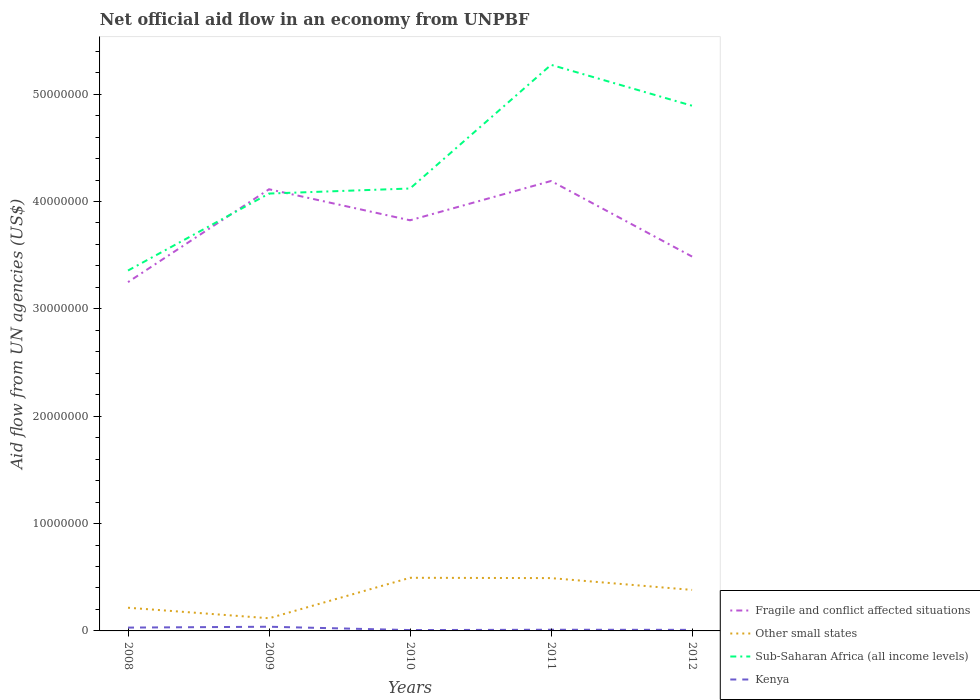How many different coloured lines are there?
Give a very brief answer. 4. What is the difference between the highest and the second highest net official aid flow in Fragile and conflict affected situations?
Your answer should be very brief. 9.42e+06. What is the difference between the highest and the lowest net official aid flow in Kenya?
Keep it short and to the point. 2. How many lines are there?
Your answer should be very brief. 4. How many years are there in the graph?
Your answer should be compact. 5. Are the values on the major ticks of Y-axis written in scientific E-notation?
Your answer should be compact. No. Does the graph contain any zero values?
Make the answer very short. No. Does the graph contain grids?
Provide a succinct answer. No. Where does the legend appear in the graph?
Your answer should be very brief. Bottom right. How many legend labels are there?
Make the answer very short. 4. How are the legend labels stacked?
Provide a succinct answer. Vertical. What is the title of the graph?
Keep it short and to the point. Net official aid flow in an economy from UNPBF. What is the label or title of the Y-axis?
Your answer should be very brief. Aid flow from UN agencies (US$). What is the Aid flow from UN agencies (US$) of Fragile and conflict affected situations in 2008?
Your answer should be compact. 3.25e+07. What is the Aid flow from UN agencies (US$) in Other small states in 2008?
Your answer should be very brief. 2.16e+06. What is the Aid flow from UN agencies (US$) in Sub-Saharan Africa (all income levels) in 2008?
Your answer should be compact. 3.36e+07. What is the Aid flow from UN agencies (US$) in Fragile and conflict affected situations in 2009?
Your answer should be very brief. 4.11e+07. What is the Aid flow from UN agencies (US$) in Other small states in 2009?
Give a very brief answer. 1.18e+06. What is the Aid flow from UN agencies (US$) in Sub-Saharan Africa (all income levels) in 2009?
Offer a terse response. 4.07e+07. What is the Aid flow from UN agencies (US$) in Fragile and conflict affected situations in 2010?
Your answer should be compact. 3.82e+07. What is the Aid flow from UN agencies (US$) in Other small states in 2010?
Offer a terse response. 4.95e+06. What is the Aid flow from UN agencies (US$) of Sub-Saharan Africa (all income levels) in 2010?
Give a very brief answer. 4.12e+07. What is the Aid flow from UN agencies (US$) of Fragile and conflict affected situations in 2011?
Your answer should be compact. 4.19e+07. What is the Aid flow from UN agencies (US$) in Other small states in 2011?
Your answer should be compact. 4.92e+06. What is the Aid flow from UN agencies (US$) in Sub-Saharan Africa (all income levels) in 2011?
Keep it short and to the point. 5.27e+07. What is the Aid flow from UN agencies (US$) in Fragile and conflict affected situations in 2012?
Provide a succinct answer. 3.49e+07. What is the Aid flow from UN agencies (US$) of Other small states in 2012?
Give a very brief answer. 3.82e+06. What is the Aid flow from UN agencies (US$) of Sub-Saharan Africa (all income levels) in 2012?
Provide a short and direct response. 4.89e+07. What is the Aid flow from UN agencies (US$) in Kenya in 2012?
Give a very brief answer. 1.00e+05. Across all years, what is the maximum Aid flow from UN agencies (US$) in Fragile and conflict affected situations?
Give a very brief answer. 4.19e+07. Across all years, what is the maximum Aid flow from UN agencies (US$) in Other small states?
Offer a very short reply. 4.95e+06. Across all years, what is the maximum Aid flow from UN agencies (US$) of Sub-Saharan Africa (all income levels)?
Give a very brief answer. 5.27e+07. Across all years, what is the maximum Aid flow from UN agencies (US$) in Kenya?
Keep it short and to the point. 3.90e+05. Across all years, what is the minimum Aid flow from UN agencies (US$) of Fragile and conflict affected situations?
Provide a succinct answer. 3.25e+07. Across all years, what is the minimum Aid flow from UN agencies (US$) of Other small states?
Keep it short and to the point. 1.18e+06. Across all years, what is the minimum Aid flow from UN agencies (US$) in Sub-Saharan Africa (all income levels)?
Offer a very short reply. 3.36e+07. Across all years, what is the minimum Aid flow from UN agencies (US$) of Kenya?
Offer a terse response. 8.00e+04. What is the total Aid flow from UN agencies (US$) in Fragile and conflict affected situations in the graph?
Keep it short and to the point. 1.89e+08. What is the total Aid flow from UN agencies (US$) of Other small states in the graph?
Keep it short and to the point. 1.70e+07. What is the total Aid flow from UN agencies (US$) of Sub-Saharan Africa (all income levels) in the graph?
Your answer should be very brief. 2.17e+08. What is the total Aid flow from UN agencies (US$) of Kenya in the graph?
Provide a short and direct response. 9.90e+05. What is the difference between the Aid flow from UN agencies (US$) in Fragile and conflict affected situations in 2008 and that in 2009?
Offer a terse response. -8.65e+06. What is the difference between the Aid flow from UN agencies (US$) in Other small states in 2008 and that in 2009?
Offer a terse response. 9.80e+05. What is the difference between the Aid flow from UN agencies (US$) in Sub-Saharan Africa (all income levels) in 2008 and that in 2009?
Offer a very short reply. -7.17e+06. What is the difference between the Aid flow from UN agencies (US$) of Fragile and conflict affected situations in 2008 and that in 2010?
Offer a terse response. -5.76e+06. What is the difference between the Aid flow from UN agencies (US$) in Other small states in 2008 and that in 2010?
Make the answer very short. -2.79e+06. What is the difference between the Aid flow from UN agencies (US$) in Sub-Saharan Africa (all income levels) in 2008 and that in 2010?
Make the answer very short. -7.64e+06. What is the difference between the Aid flow from UN agencies (US$) of Kenya in 2008 and that in 2010?
Your answer should be compact. 2.30e+05. What is the difference between the Aid flow from UN agencies (US$) of Fragile and conflict affected situations in 2008 and that in 2011?
Provide a short and direct response. -9.42e+06. What is the difference between the Aid flow from UN agencies (US$) in Other small states in 2008 and that in 2011?
Offer a very short reply. -2.76e+06. What is the difference between the Aid flow from UN agencies (US$) of Sub-Saharan Africa (all income levels) in 2008 and that in 2011?
Ensure brevity in your answer.  -1.92e+07. What is the difference between the Aid flow from UN agencies (US$) of Kenya in 2008 and that in 2011?
Ensure brevity in your answer.  2.00e+05. What is the difference between the Aid flow from UN agencies (US$) of Fragile and conflict affected situations in 2008 and that in 2012?
Ensure brevity in your answer.  -2.38e+06. What is the difference between the Aid flow from UN agencies (US$) of Other small states in 2008 and that in 2012?
Offer a terse response. -1.66e+06. What is the difference between the Aid flow from UN agencies (US$) of Sub-Saharan Africa (all income levels) in 2008 and that in 2012?
Provide a succinct answer. -1.54e+07. What is the difference between the Aid flow from UN agencies (US$) of Kenya in 2008 and that in 2012?
Provide a short and direct response. 2.10e+05. What is the difference between the Aid flow from UN agencies (US$) of Fragile and conflict affected situations in 2009 and that in 2010?
Your answer should be compact. 2.89e+06. What is the difference between the Aid flow from UN agencies (US$) of Other small states in 2009 and that in 2010?
Keep it short and to the point. -3.77e+06. What is the difference between the Aid flow from UN agencies (US$) in Sub-Saharan Africa (all income levels) in 2009 and that in 2010?
Ensure brevity in your answer.  -4.70e+05. What is the difference between the Aid flow from UN agencies (US$) of Fragile and conflict affected situations in 2009 and that in 2011?
Give a very brief answer. -7.70e+05. What is the difference between the Aid flow from UN agencies (US$) in Other small states in 2009 and that in 2011?
Your response must be concise. -3.74e+06. What is the difference between the Aid flow from UN agencies (US$) in Sub-Saharan Africa (all income levels) in 2009 and that in 2011?
Provide a succinct answer. -1.20e+07. What is the difference between the Aid flow from UN agencies (US$) of Kenya in 2009 and that in 2011?
Ensure brevity in your answer.  2.80e+05. What is the difference between the Aid flow from UN agencies (US$) of Fragile and conflict affected situations in 2009 and that in 2012?
Offer a very short reply. 6.27e+06. What is the difference between the Aid flow from UN agencies (US$) in Other small states in 2009 and that in 2012?
Ensure brevity in your answer.  -2.64e+06. What is the difference between the Aid flow from UN agencies (US$) of Sub-Saharan Africa (all income levels) in 2009 and that in 2012?
Ensure brevity in your answer.  -8.18e+06. What is the difference between the Aid flow from UN agencies (US$) in Kenya in 2009 and that in 2012?
Ensure brevity in your answer.  2.90e+05. What is the difference between the Aid flow from UN agencies (US$) in Fragile and conflict affected situations in 2010 and that in 2011?
Offer a very short reply. -3.66e+06. What is the difference between the Aid flow from UN agencies (US$) in Sub-Saharan Africa (all income levels) in 2010 and that in 2011?
Your response must be concise. -1.15e+07. What is the difference between the Aid flow from UN agencies (US$) of Kenya in 2010 and that in 2011?
Give a very brief answer. -3.00e+04. What is the difference between the Aid flow from UN agencies (US$) of Fragile and conflict affected situations in 2010 and that in 2012?
Offer a terse response. 3.38e+06. What is the difference between the Aid flow from UN agencies (US$) of Other small states in 2010 and that in 2012?
Ensure brevity in your answer.  1.13e+06. What is the difference between the Aid flow from UN agencies (US$) in Sub-Saharan Africa (all income levels) in 2010 and that in 2012?
Offer a terse response. -7.71e+06. What is the difference between the Aid flow from UN agencies (US$) in Kenya in 2010 and that in 2012?
Provide a succinct answer. -2.00e+04. What is the difference between the Aid flow from UN agencies (US$) in Fragile and conflict affected situations in 2011 and that in 2012?
Ensure brevity in your answer.  7.04e+06. What is the difference between the Aid flow from UN agencies (US$) in Other small states in 2011 and that in 2012?
Provide a short and direct response. 1.10e+06. What is the difference between the Aid flow from UN agencies (US$) of Sub-Saharan Africa (all income levels) in 2011 and that in 2012?
Provide a short and direct response. 3.81e+06. What is the difference between the Aid flow from UN agencies (US$) in Kenya in 2011 and that in 2012?
Keep it short and to the point. 10000. What is the difference between the Aid flow from UN agencies (US$) of Fragile and conflict affected situations in 2008 and the Aid flow from UN agencies (US$) of Other small states in 2009?
Your response must be concise. 3.13e+07. What is the difference between the Aid flow from UN agencies (US$) in Fragile and conflict affected situations in 2008 and the Aid flow from UN agencies (US$) in Sub-Saharan Africa (all income levels) in 2009?
Your response must be concise. -8.25e+06. What is the difference between the Aid flow from UN agencies (US$) of Fragile and conflict affected situations in 2008 and the Aid flow from UN agencies (US$) of Kenya in 2009?
Provide a succinct answer. 3.21e+07. What is the difference between the Aid flow from UN agencies (US$) of Other small states in 2008 and the Aid flow from UN agencies (US$) of Sub-Saharan Africa (all income levels) in 2009?
Keep it short and to the point. -3.86e+07. What is the difference between the Aid flow from UN agencies (US$) of Other small states in 2008 and the Aid flow from UN agencies (US$) of Kenya in 2009?
Provide a succinct answer. 1.77e+06. What is the difference between the Aid flow from UN agencies (US$) in Sub-Saharan Africa (all income levels) in 2008 and the Aid flow from UN agencies (US$) in Kenya in 2009?
Ensure brevity in your answer.  3.32e+07. What is the difference between the Aid flow from UN agencies (US$) in Fragile and conflict affected situations in 2008 and the Aid flow from UN agencies (US$) in Other small states in 2010?
Your response must be concise. 2.75e+07. What is the difference between the Aid flow from UN agencies (US$) in Fragile and conflict affected situations in 2008 and the Aid flow from UN agencies (US$) in Sub-Saharan Africa (all income levels) in 2010?
Your answer should be compact. -8.72e+06. What is the difference between the Aid flow from UN agencies (US$) in Fragile and conflict affected situations in 2008 and the Aid flow from UN agencies (US$) in Kenya in 2010?
Your answer should be very brief. 3.24e+07. What is the difference between the Aid flow from UN agencies (US$) in Other small states in 2008 and the Aid flow from UN agencies (US$) in Sub-Saharan Africa (all income levels) in 2010?
Offer a terse response. -3.90e+07. What is the difference between the Aid flow from UN agencies (US$) of Other small states in 2008 and the Aid flow from UN agencies (US$) of Kenya in 2010?
Provide a succinct answer. 2.08e+06. What is the difference between the Aid flow from UN agencies (US$) of Sub-Saharan Africa (all income levels) in 2008 and the Aid flow from UN agencies (US$) of Kenya in 2010?
Give a very brief answer. 3.35e+07. What is the difference between the Aid flow from UN agencies (US$) of Fragile and conflict affected situations in 2008 and the Aid flow from UN agencies (US$) of Other small states in 2011?
Ensure brevity in your answer.  2.76e+07. What is the difference between the Aid flow from UN agencies (US$) of Fragile and conflict affected situations in 2008 and the Aid flow from UN agencies (US$) of Sub-Saharan Africa (all income levels) in 2011?
Offer a terse response. -2.02e+07. What is the difference between the Aid flow from UN agencies (US$) of Fragile and conflict affected situations in 2008 and the Aid flow from UN agencies (US$) of Kenya in 2011?
Give a very brief answer. 3.24e+07. What is the difference between the Aid flow from UN agencies (US$) in Other small states in 2008 and the Aid flow from UN agencies (US$) in Sub-Saharan Africa (all income levels) in 2011?
Give a very brief answer. -5.06e+07. What is the difference between the Aid flow from UN agencies (US$) in Other small states in 2008 and the Aid flow from UN agencies (US$) in Kenya in 2011?
Give a very brief answer. 2.05e+06. What is the difference between the Aid flow from UN agencies (US$) in Sub-Saharan Africa (all income levels) in 2008 and the Aid flow from UN agencies (US$) in Kenya in 2011?
Provide a short and direct response. 3.35e+07. What is the difference between the Aid flow from UN agencies (US$) of Fragile and conflict affected situations in 2008 and the Aid flow from UN agencies (US$) of Other small states in 2012?
Offer a terse response. 2.87e+07. What is the difference between the Aid flow from UN agencies (US$) of Fragile and conflict affected situations in 2008 and the Aid flow from UN agencies (US$) of Sub-Saharan Africa (all income levels) in 2012?
Your answer should be very brief. -1.64e+07. What is the difference between the Aid flow from UN agencies (US$) of Fragile and conflict affected situations in 2008 and the Aid flow from UN agencies (US$) of Kenya in 2012?
Offer a terse response. 3.24e+07. What is the difference between the Aid flow from UN agencies (US$) of Other small states in 2008 and the Aid flow from UN agencies (US$) of Sub-Saharan Africa (all income levels) in 2012?
Make the answer very short. -4.68e+07. What is the difference between the Aid flow from UN agencies (US$) in Other small states in 2008 and the Aid flow from UN agencies (US$) in Kenya in 2012?
Keep it short and to the point. 2.06e+06. What is the difference between the Aid flow from UN agencies (US$) in Sub-Saharan Africa (all income levels) in 2008 and the Aid flow from UN agencies (US$) in Kenya in 2012?
Your response must be concise. 3.35e+07. What is the difference between the Aid flow from UN agencies (US$) of Fragile and conflict affected situations in 2009 and the Aid flow from UN agencies (US$) of Other small states in 2010?
Keep it short and to the point. 3.62e+07. What is the difference between the Aid flow from UN agencies (US$) of Fragile and conflict affected situations in 2009 and the Aid flow from UN agencies (US$) of Kenya in 2010?
Offer a terse response. 4.11e+07. What is the difference between the Aid flow from UN agencies (US$) in Other small states in 2009 and the Aid flow from UN agencies (US$) in Sub-Saharan Africa (all income levels) in 2010?
Offer a very short reply. -4.00e+07. What is the difference between the Aid flow from UN agencies (US$) in Other small states in 2009 and the Aid flow from UN agencies (US$) in Kenya in 2010?
Offer a very short reply. 1.10e+06. What is the difference between the Aid flow from UN agencies (US$) of Sub-Saharan Africa (all income levels) in 2009 and the Aid flow from UN agencies (US$) of Kenya in 2010?
Provide a succinct answer. 4.07e+07. What is the difference between the Aid flow from UN agencies (US$) in Fragile and conflict affected situations in 2009 and the Aid flow from UN agencies (US$) in Other small states in 2011?
Make the answer very short. 3.62e+07. What is the difference between the Aid flow from UN agencies (US$) of Fragile and conflict affected situations in 2009 and the Aid flow from UN agencies (US$) of Sub-Saharan Africa (all income levels) in 2011?
Give a very brief answer. -1.16e+07. What is the difference between the Aid flow from UN agencies (US$) of Fragile and conflict affected situations in 2009 and the Aid flow from UN agencies (US$) of Kenya in 2011?
Give a very brief answer. 4.10e+07. What is the difference between the Aid flow from UN agencies (US$) in Other small states in 2009 and the Aid flow from UN agencies (US$) in Sub-Saharan Africa (all income levels) in 2011?
Keep it short and to the point. -5.16e+07. What is the difference between the Aid flow from UN agencies (US$) in Other small states in 2009 and the Aid flow from UN agencies (US$) in Kenya in 2011?
Your answer should be very brief. 1.07e+06. What is the difference between the Aid flow from UN agencies (US$) in Sub-Saharan Africa (all income levels) in 2009 and the Aid flow from UN agencies (US$) in Kenya in 2011?
Your response must be concise. 4.06e+07. What is the difference between the Aid flow from UN agencies (US$) in Fragile and conflict affected situations in 2009 and the Aid flow from UN agencies (US$) in Other small states in 2012?
Provide a succinct answer. 3.73e+07. What is the difference between the Aid flow from UN agencies (US$) in Fragile and conflict affected situations in 2009 and the Aid flow from UN agencies (US$) in Sub-Saharan Africa (all income levels) in 2012?
Offer a terse response. -7.78e+06. What is the difference between the Aid flow from UN agencies (US$) in Fragile and conflict affected situations in 2009 and the Aid flow from UN agencies (US$) in Kenya in 2012?
Give a very brief answer. 4.10e+07. What is the difference between the Aid flow from UN agencies (US$) of Other small states in 2009 and the Aid flow from UN agencies (US$) of Sub-Saharan Africa (all income levels) in 2012?
Offer a terse response. -4.77e+07. What is the difference between the Aid flow from UN agencies (US$) of Other small states in 2009 and the Aid flow from UN agencies (US$) of Kenya in 2012?
Keep it short and to the point. 1.08e+06. What is the difference between the Aid flow from UN agencies (US$) in Sub-Saharan Africa (all income levels) in 2009 and the Aid flow from UN agencies (US$) in Kenya in 2012?
Your response must be concise. 4.06e+07. What is the difference between the Aid flow from UN agencies (US$) of Fragile and conflict affected situations in 2010 and the Aid flow from UN agencies (US$) of Other small states in 2011?
Your response must be concise. 3.33e+07. What is the difference between the Aid flow from UN agencies (US$) in Fragile and conflict affected situations in 2010 and the Aid flow from UN agencies (US$) in Sub-Saharan Africa (all income levels) in 2011?
Offer a terse response. -1.45e+07. What is the difference between the Aid flow from UN agencies (US$) in Fragile and conflict affected situations in 2010 and the Aid flow from UN agencies (US$) in Kenya in 2011?
Ensure brevity in your answer.  3.81e+07. What is the difference between the Aid flow from UN agencies (US$) of Other small states in 2010 and the Aid flow from UN agencies (US$) of Sub-Saharan Africa (all income levels) in 2011?
Your answer should be compact. -4.78e+07. What is the difference between the Aid flow from UN agencies (US$) in Other small states in 2010 and the Aid flow from UN agencies (US$) in Kenya in 2011?
Your answer should be very brief. 4.84e+06. What is the difference between the Aid flow from UN agencies (US$) of Sub-Saharan Africa (all income levels) in 2010 and the Aid flow from UN agencies (US$) of Kenya in 2011?
Your response must be concise. 4.11e+07. What is the difference between the Aid flow from UN agencies (US$) of Fragile and conflict affected situations in 2010 and the Aid flow from UN agencies (US$) of Other small states in 2012?
Your answer should be compact. 3.44e+07. What is the difference between the Aid flow from UN agencies (US$) in Fragile and conflict affected situations in 2010 and the Aid flow from UN agencies (US$) in Sub-Saharan Africa (all income levels) in 2012?
Offer a very short reply. -1.07e+07. What is the difference between the Aid flow from UN agencies (US$) in Fragile and conflict affected situations in 2010 and the Aid flow from UN agencies (US$) in Kenya in 2012?
Your answer should be very brief. 3.82e+07. What is the difference between the Aid flow from UN agencies (US$) of Other small states in 2010 and the Aid flow from UN agencies (US$) of Sub-Saharan Africa (all income levels) in 2012?
Provide a succinct answer. -4.40e+07. What is the difference between the Aid flow from UN agencies (US$) in Other small states in 2010 and the Aid flow from UN agencies (US$) in Kenya in 2012?
Give a very brief answer. 4.85e+06. What is the difference between the Aid flow from UN agencies (US$) in Sub-Saharan Africa (all income levels) in 2010 and the Aid flow from UN agencies (US$) in Kenya in 2012?
Make the answer very short. 4.11e+07. What is the difference between the Aid flow from UN agencies (US$) of Fragile and conflict affected situations in 2011 and the Aid flow from UN agencies (US$) of Other small states in 2012?
Keep it short and to the point. 3.81e+07. What is the difference between the Aid flow from UN agencies (US$) of Fragile and conflict affected situations in 2011 and the Aid flow from UN agencies (US$) of Sub-Saharan Africa (all income levels) in 2012?
Ensure brevity in your answer.  -7.01e+06. What is the difference between the Aid flow from UN agencies (US$) of Fragile and conflict affected situations in 2011 and the Aid flow from UN agencies (US$) of Kenya in 2012?
Offer a very short reply. 4.18e+07. What is the difference between the Aid flow from UN agencies (US$) of Other small states in 2011 and the Aid flow from UN agencies (US$) of Sub-Saharan Africa (all income levels) in 2012?
Your answer should be compact. -4.40e+07. What is the difference between the Aid flow from UN agencies (US$) of Other small states in 2011 and the Aid flow from UN agencies (US$) of Kenya in 2012?
Your answer should be very brief. 4.82e+06. What is the difference between the Aid flow from UN agencies (US$) in Sub-Saharan Africa (all income levels) in 2011 and the Aid flow from UN agencies (US$) in Kenya in 2012?
Ensure brevity in your answer.  5.26e+07. What is the average Aid flow from UN agencies (US$) of Fragile and conflict affected situations per year?
Offer a terse response. 3.77e+07. What is the average Aid flow from UN agencies (US$) in Other small states per year?
Ensure brevity in your answer.  3.41e+06. What is the average Aid flow from UN agencies (US$) of Sub-Saharan Africa (all income levels) per year?
Offer a very short reply. 4.34e+07. What is the average Aid flow from UN agencies (US$) in Kenya per year?
Provide a succinct answer. 1.98e+05. In the year 2008, what is the difference between the Aid flow from UN agencies (US$) of Fragile and conflict affected situations and Aid flow from UN agencies (US$) of Other small states?
Your answer should be compact. 3.03e+07. In the year 2008, what is the difference between the Aid flow from UN agencies (US$) in Fragile and conflict affected situations and Aid flow from UN agencies (US$) in Sub-Saharan Africa (all income levels)?
Your response must be concise. -1.08e+06. In the year 2008, what is the difference between the Aid flow from UN agencies (US$) of Fragile and conflict affected situations and Aid flow from UN agencies (US$) of Kenya?
Your answer should be very brief. 3.22e+07. In the year 2008, what is the difference between the Aid flow from UN agencies (US$) of Other small states and Aid flow from UN agencies (US$) of Sub-Saharan Africa (all income levels)?
Give a very brief answer. -3.14e+07. In the year 2008, what is the difference between the Aid flow from UN agencies (US$) in Other small states and Aid flow from UN agencies (US$) in Kenya?
Your answer should be compact. 1.85e+06. In the year 2008, what is the difference between the Aid flow from UN agencies (US$) of Sub-Saharan Africa (all income levels) and Aid flow from UN agencies (US$) of Kenya?
Make the answer very short. 3.33e+07. In the year 2009, what is the difference between the Aid flow from UN agencies (US$) in Fragile and conflict affected situations and Aid flow from UN agencies (US$) in Other small states?
Provide a succinct answer. 4.00e+07. In the year 2009, what is the difference between the Aid flow from UN agencies (US$) of Fragile and conflict affected situations and Aid flow from UN agencies (US$) of Sub-Saharan Africa (all income levels)?
Provide a short and direct response. 4.00e+05. In the year 2009, what is the difference between the Aid flow from UN agencies (US$) of Fragile and conflict affected situations and Aid flow from UN agencies (US$) of Kenya?
Your response must be concise. 4.08e+07. In the year 2009, what is the difference between the Aid flow from UN agencies (US$) in Other small states and Aid flow from UN agencies (US$) in Sub-Saharan Africa (all income levels)?
Your answer should be very brief. -3.96e+07. In the year 2009, what is the difference between the Aid flow from UN agencies (US$) in Other small states and Aid flow from UN agencies (US$) in Kenya?
Provide a succinct answer. 7.90e+05. In the year 2009, what is the difference between the Aid flow from UN agencies (US$) of Sub-Saharan Africa (all income levels) and Aid flow from UN agencies (US$) of Kenya?
Provide a succinct answer. 4.04e+07. In the year 2010, what is the difference between the Aid flow from UN agencies (US$) of Fragile and conflict affected situations and Aid flow from UN agencies (US$) of Other small states?
Keep it short and to the point. 3.33e+07. In the year 2010, what is the difference between the Aid flow from UN agencies (US$) of Fragile and conflict affected situations and Aid flow from UN agencies (US$) of Sub-Saharan Africa (all income levels)?
Give a very brief answer. -2.96e+06. In the year 2010, what is the difference between the Aid flow from UN agencies (US$) of Fragile and conflict affected situations and Aid flow from UN agencies (US$) of Kenya?
Provide a short and direct response. 3.82e+07. In the year 2010, what is the difference between the Aid flow from UN agencies (US$) of Other small states and Aid flow from UN agencies (US$) of Sub-Saharan Africa (all income levels)?
Give a very brief answer. -3.63e+07. In the year 2010, what is the difference between the Aid flow from UN agencies (US$) in Other small states and Aid flow from UN agencies (US$) in Kenya?
Offer a terse response. 4.87e+06. In the year 2010, what is the difference between the Aid flow from UN agencies (US$) of Sub-Saharan Africa (all income levels) and Aid flow from UN agencies (US$) of Kenya?
Provide a short and direct response. 4.11e+07. In the year 2011, what is the difference between the Aid flow from UN agencies (US$) of Fragile and conflict affected situations and Aid flow from UN agencies (US$) of Other small states?
Keep it short and to the point. 3.70e+07. In the year 2011, what is the difference between the Aid flow from UN agencies (US$) of Fragile and conflict affected situations and Aid flow from UN agencies (US$) of Sub-Saharan Africa (all income levels)?
Your response must be concise. -1.08e+07. In the year 2011, what is the difference between the Aid flow from UN agencies (US$) of Fragile and conflict affected situations and Aid flow from UN agencies (US$) of Kenya?
Your answer should be compact. 4.18e+07. In the year 2011, what is the difference between the Aid flow from UN agencies (US$) of Other small states and Aid flow from UN agencies (US$) of Sub-Saharan Africa (all income levels)?
Provide a succinct answer. -4.78e+07. In the year 2011, what is the difference between the Aid flow from UN agencies (US$) of Other small states and Aid flow from UN agencies (US$) of Kenya?
Your answer should be compact. 4.81e+06. In the year 2011, what is the difference between the Aid flow from UN agencies (US$) in Sub-Saharan Africa (all income levels) and Aid flow from UN agencies (US$) in Kenya?
Offer a terse response. 5.26e+07. In the year 2012, what is the difference between the Aid flow from UN agencies (US$) in Fragile and conflict affected situations and Aid flow from UN agencies (US$) in Other small states?
Your response must be concise. 3.10e+07. In the year 2012, what is the difference between the Aid flow from UN agencies (US$) of Fragile and conflict affected situations and Aid flow from UN agencies (US$) of Sub-Saharan Africa (all income levels)?
Ensure brevity in your answer.  -1.40e+07. In the year 2012, what is the difference between the Aid flow from UN agencies (US$) of Fragile and conflict affected situations and Aid flow from UN agencies (US$) of Kenya?
Provide a short and direct response. 3.48e+07. In the year 2012, what is the difference between the Aid flow from UN agencies (US$) of Other small states and Aid flow from UN agencies (US$) of Sub-Saharan Africa (all income levels)?
Provide a short and direct response. -4.51e+07. In the year 2012, what is the difference between the Aid flow from UN agencies (US$) in Other small states and Aid flow from UN agencies (US$) in Kenya?
Offer a very short reply. 3.72e+06. In the year 2012, what is the difference between the Aid flow from UN agencies (US$) of Sub-Saharan Africa (all income levels) and Aid flow from UN agencies (US$) of Kenya?
Offer a very short reply. 4.88e+07. What is the ratio of the Aid flow from UN agencies (US$) in Fragile and conflict affected situations in 2008 to that in 2009?
Your response must be concise. 0.79. What is the ratio of the Aid flow from UN agencies (US$) of Other small states in 2008 to that in 2009?
Provide a short and direct response. 1.83. What is the ratio of the Aid flow from UN agencies (US$) in Sub-Saharan Africa (all income levels) in 2008 to that in 2009?
Your answer should be very brief. 0.82. What is the ratio of the Aid flow from UN agencies (US$) of Kenya in 2008 to that in 2009?
Keep it short and to the point. 0.79. What is the ratio of the Aid flow from UN agencies (US$) of Fragile and conflict affected situations in 2008 to that in 2010?
Your answer should be very brief. 0.85. What is the ratio of the Aid flow from UN agencies (US$) of Other small states in 2008 to that in 2010?
Your answer should be very brief. 0.44. What is the ratio of the Aid flow from UN agencies (US$) of Sub-Saharan Africa (all income levels) in 2008 to that in 2010?
Make the answer very short. 0.81. What is the ratio of the Aid flow from UN agencies (US$) in Kenya in 2008 to that in 2010?
Provide a short and direct response. 3.88. What is the ratio of the Aid flow from UN agencies (US$) in Fragile and conflict affected situations in 2008 to that in 2011?
Your answer should be compact. 0.78. What is the ratio of the Aid flow from UN agencies (US$) of Other small states in 2008 to that in 2011?
Offer a very short reply. 0.44. What is the ratio of the Aid flow from UN agencies (US$) in Sub-Saharan Africa (all income levels) in 2008 to that in 2011?
Provide a succinct answer. 0.64. What is the ratio of the Aid flow from UN agencies (US$) in Kenya in 2008 to that in 2011?
Your answer should be compact. 2.82. What is the ratio of the Aid flow from UN agencies (US$) of Fragile and conflict affected situations in 2008 to that in 2012?
Offer a very short reply. 0.93. What is the ratio of the Aid flow from UN agencies (US$) in Other small states in 2008 to that in 2012?
Keep it short and to the point. 0.57. What is the ratio of the Aid flow from UN agencies (US$) of Sub-Saharan Africa (all income levels) in 2008 to that in 2012?
Offer a very short reply. 0.69. What is the ratio of the Aid flow from UN agencies (US$) in Fragile and conflict affected situations in 2009 to that in 2010?
Give a very brief answer. 1.08. What is the ratio of the Aid flow from UN agencies (US$) in Other small states in 2009 to that in 2010?
Ensure brevity in your answer.  0.24. What is the ratio of the Aid flow from UN agencies (US$) in Sub-Saharan Africa (all income levels) in 2009 to that in 2010?
Your answer should be very brief. 0.99. What is the ratio of the Aid flow from UN agencies (US$) of Kenya in 2009 to that in 2010?
Your answer should be compact. 4.88. What is the ratio of the Aid flow from UN agencies (US$) of Fragile and conflict affected situations in 2009 to that in 2011?
Ensure brevity in your answer.  0.98. What is the ratio of the Aid flow from UN agencies (US$) of Other small states in 2009 to that in 2011?
Provide a succinct answer. 0.24. What is the ratio of the Aid flow from UN agencies (US$) of Sub-Saharan Africa (all income levels) in 2009 to that in 2011?
Give a very brief answer. 0.77. What is the ratio of the Aid flow from UN agencies (US$) in Kenya in 2009 to that in 2011?
Keep it short and to the point. 3.55. What is the ratio of the Aid flow from UN agencies (US$) in Fragile and conflict affected situations in 2009 to that in 2012?
Offer a very short reply. 1.18. What is the ratio of the Aid flow from UN agencies (US$) of Other small states in 2009 to that in 2012?
Keep it short and to the point. 0.31. What is the ratio of the Aid flow from UN agencies (US$) in Sub-Saharan Africa (all income levels) in 2009 to that in 2012?
Make the answer very short. 0.83. What is the ratio of the Aid flow from UN agencies (US$) of Fragile and conflict affected situations in 2010 to that in 2011?
Provide a succinct answer. 0.91. What is the ratio of the Aid flow from UN agencies (US$) of Other small states in 2010 to that in 2011?
Offer a very short reply. 1.01. What is the ratio of the Aid flow from UN agencies (US$) of Sub-Saharan Africa (all income levels) in 2010 to that in 2011?
Ensure brevity in your answer.  0.78. What is the ratio of the Aid flow from UN agencies (US$) of Kenya in 2010 to that in 2011?
Make the answer very short. 0.73. What is the ratio of the Aid flow from UN agencies (US$) of Fragile and conflict affected situations in 2010 to that in 2012?
Your response must be concise. 1.1. What is the ratio of the Aid flow from UN agencies (US$) of Other small states in 2010 to that in 2012?
Provide a succinct answer. 1.3. What is the ratio of the Aid flow from UN agencies (US$) in Sub-Saharan Africa (all income levels) in 2010 to that in 2012?
Your response must be concise. 0.84. What is the ratio of the Aid flow from UN agencies (US$) of Kenya in 2010 to that in 2012?
Provide a succinct answer. 0.8. What is the ratio of the Aid flow from UN agencies (US$) in Fragile and conflict affected situations in 2011 to that in 2012?
Your answer should be compact. 1.2. What is the ratio of the Aid flow from UN agencies (US$) in Other small states in 2011 to that in 2012?
Your response must be concise. 1.29. What is the ratio of the Aid flow from UN agencies (US$) of Sub-Saharan Africa (all income levels) in 2011 to that in 2012?
Offer a terse response. 1.08. What is the ratio of the Aid flow from UN agencies (US$) in Kenya in 2011 to that in 2012?
Your answer should be compact. 1.1. What is the difference between the highest and the second highest Aid flow from UN agencies (US$) in Fragile and conflict affected situations?
Your answer should be compact. 7.70e+05. What is the difference between the highest and the second highest Aid flow from UN agencies (US$) of Sub-Saharan Africa (all income levels)?
Offer a very short reply. 3.81e+06. What is the difference between the highest and the lowest Aid flow from UN agencies (US$) of Fragile and conflict affected situations?
Your answer should be compact. 9.42e+06. What is the difference between the highest and the lowest Aid flow from UN agencies (US$) in Other small states?
Ensure brevity in your answer.  3.77e+06. What is the difference between the highest and the lowest Aid flow from UN agencies (US$) in Sub-Saharan Africa (all income levels)?
Your answer should be compact. 1.92e+07. 